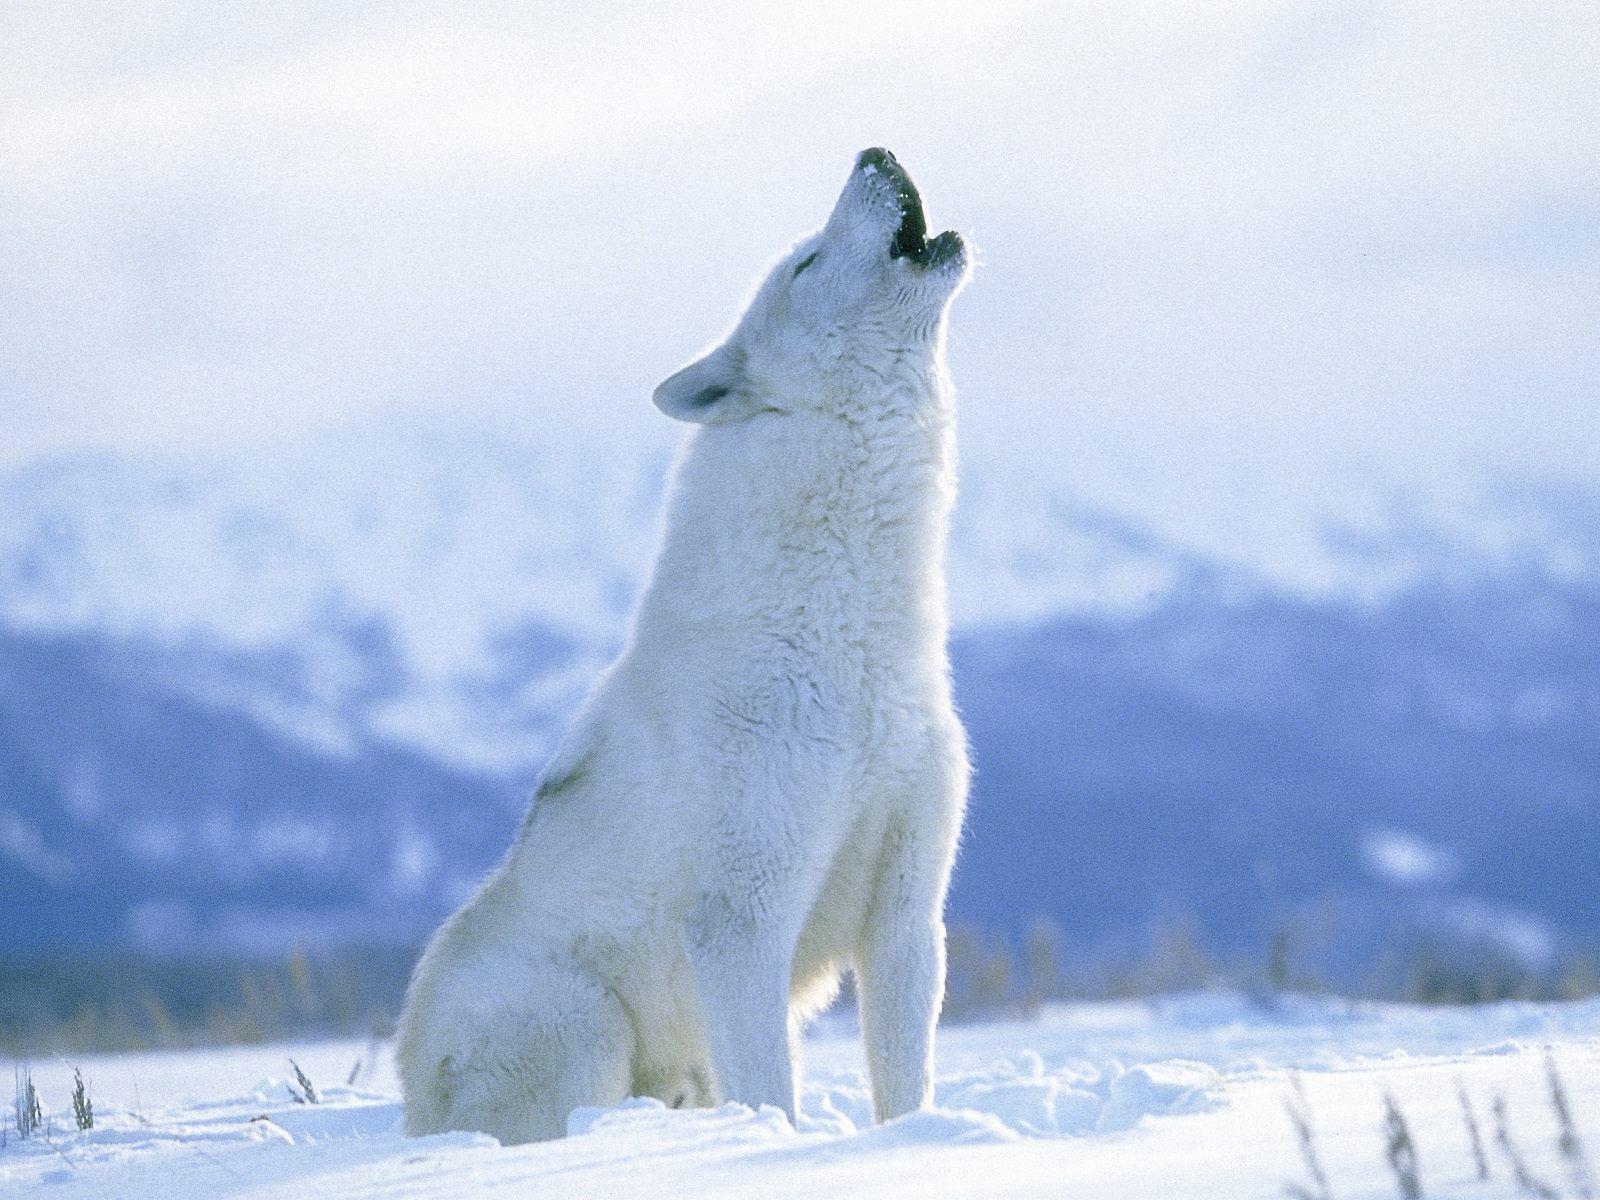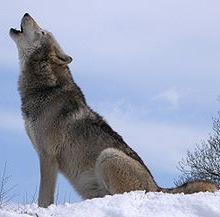The first image is the image on the left, the second image is the image on the right. Given the left and right images, does the statement "There are three wolves" hold true? Answer yes or no. No. 